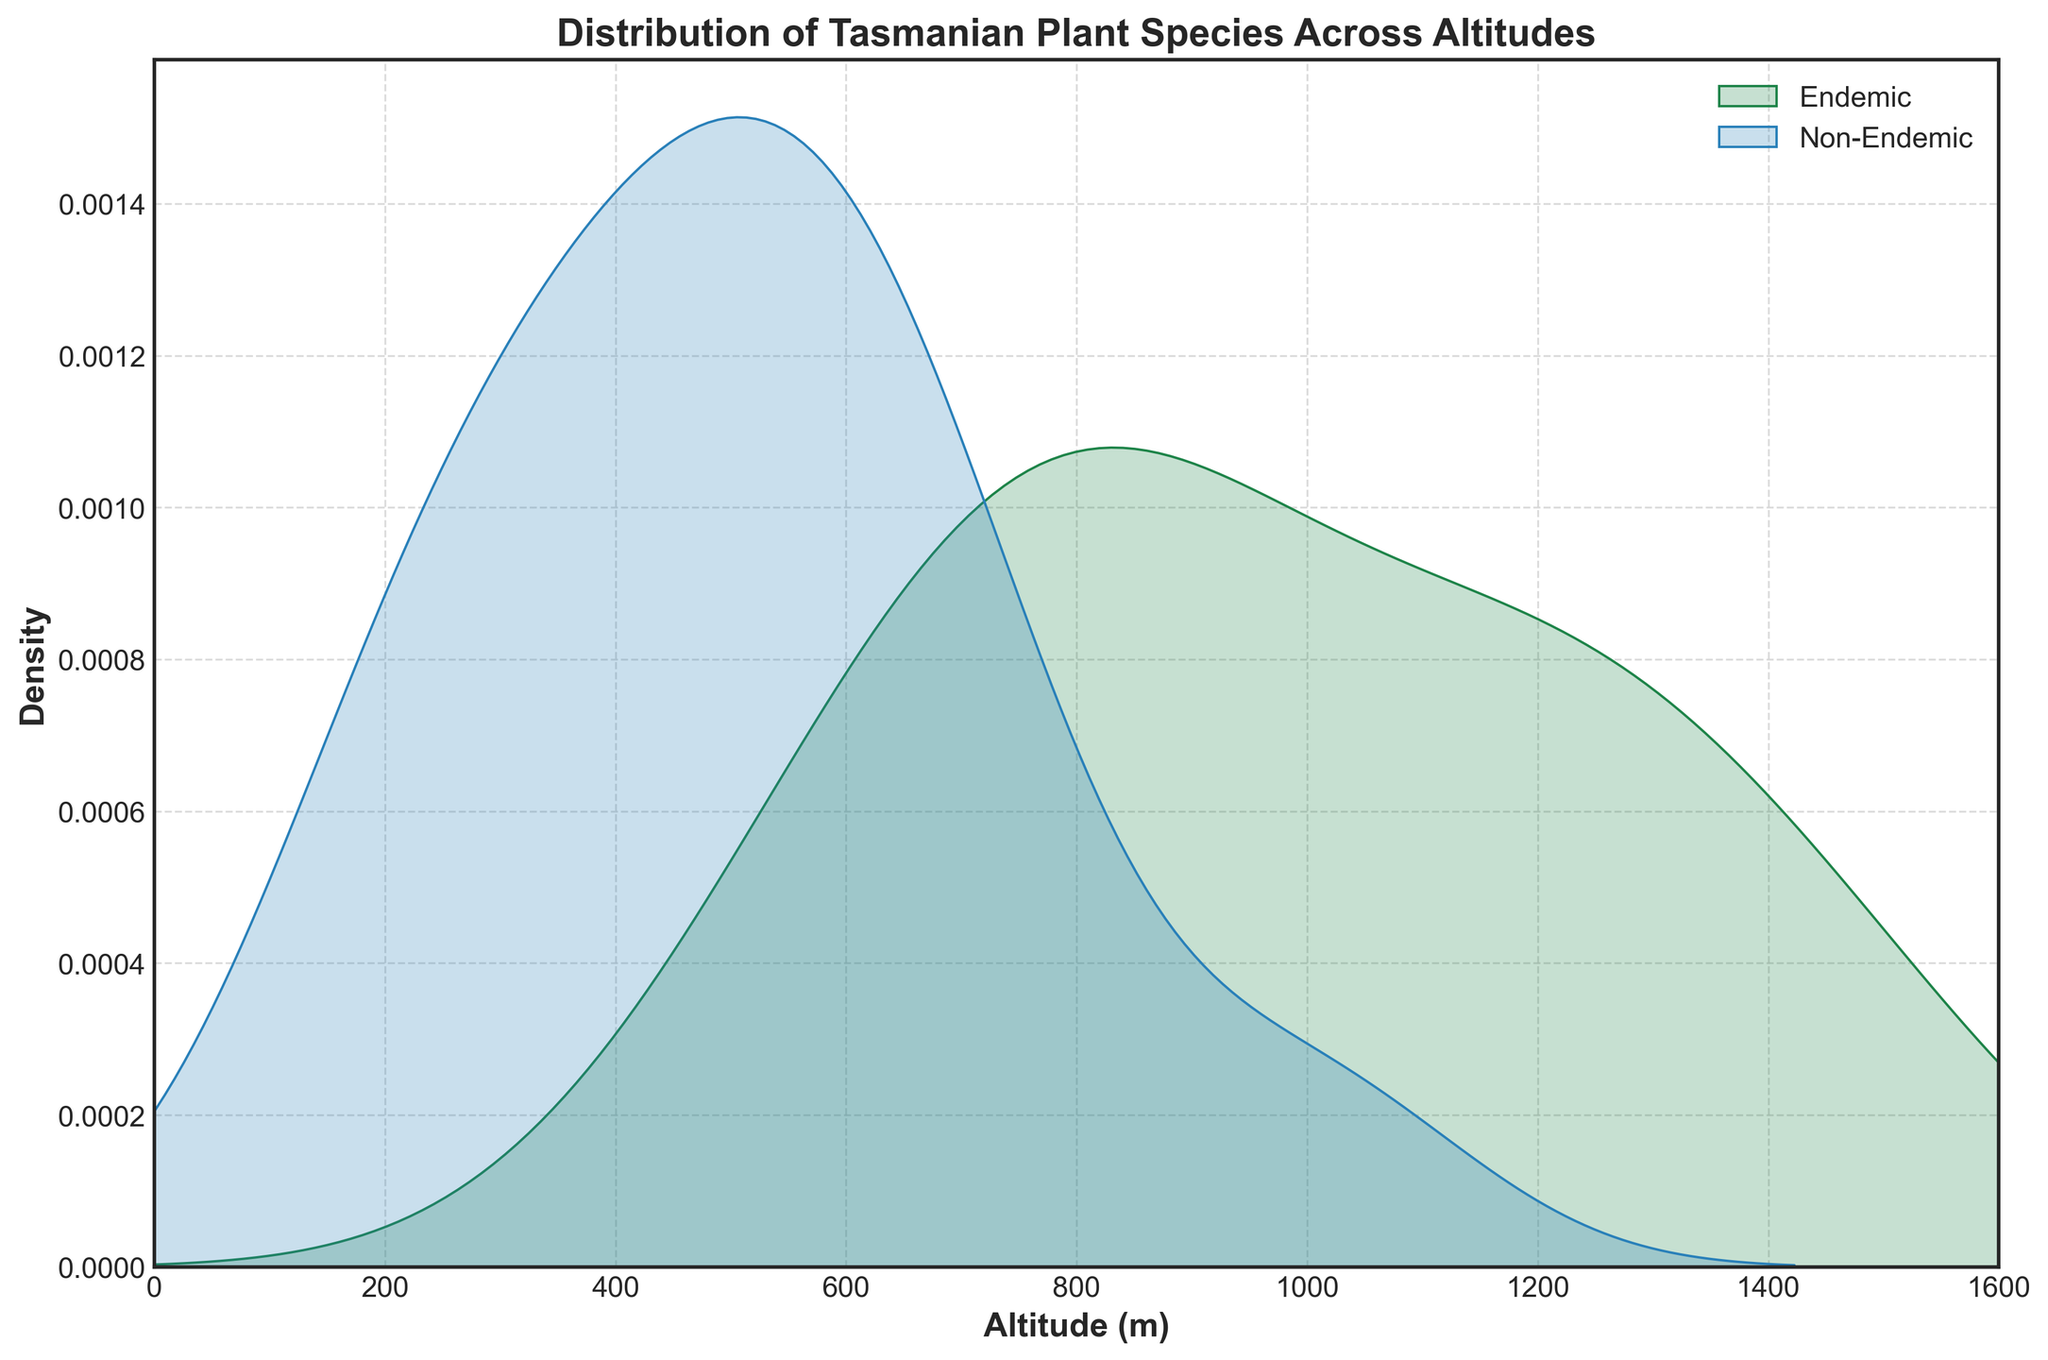What is the title of the plot? The title is usually placed at the top of the plot and provides the main description of what the plot is about. In this case, it is "Distribution of Tasmanian Plant Species Across Altitudes".
Answer: Distribution of Tasmanian Plant Species Across Altitudes What are the colors used to represent endemic and non-endemic species? The plot uses different colors to distinguish between endemic and non-endemic species, which are denoted in the legend. The color for endemic species is '#1e8449', a shade of green, and for non-endemic species is '#2980b9', a shade of blue.
Answer: Green for Endemic, Blue for Non-Endemic Which altitude range shows the highest density for endemic species? By analyzing the density plot for the endemic species (green shade), we can see that the highest peak, indicating the highest density, is around the 700-800 meter range.
Answer: 700-800 meters Do endemic or non-endemic species show a wider altitude distribution? To determine this, we compare the spread of the two density plots. The density plot of the non-endemic species (blue shade) spreads across altitudes from 200 to around 1600 meters, indicating a wider distribution compared to the endemic species (green shade), which is more concentrated between 500 and 1500 meters.
Answer: Non-Endemic species At which altitude do both endemic and non-endemic species show notable density overlap? Observing the plot, we look for altitudes where both density plots (green and blue) have overlapping areas. Notable density overlap is around the 700-900 meter range.
Answer: 700-900 meters What can be inferred about the density of species at lower altitudes (0-500 meters)? Looking at the density plots within the 0 to 500 meter range, non-endemic species (blue shade) show a significant density while endemic species (green shade) have minimal density in this range. This indicates more non-endemic species thrive at lower altitudes compared to endemic species.
Answer: More non-endemic species at lower altitudes What is the range of altitudes covered by endemic species? The altitudes covered by endemic species can be determined by noting the spread of the green density plot. Endemic species are present from approximately 500 to 1500 meters.
Answer: 500-1500 meters Are there any altitudes where no species are present according to the plot? Checking both density plots for any altitude with zero density, we see that no species are present at the extreme low (0-200 meters) and high (1500-1600 meters) ends.
Answer: 0-200 meters, 1500-1600 meters Which species group shows more peaks in their density distribution? Comparing the plot features, the density distribution of non-endemic species (blue) shows more peaks and varied density, indicating more variation in altitude preferences compared to endemic species (green).
Answer: Non-Endemic species What is the altitude range with the least density for both endemic and non-endemic species? By identifying the altitude ranges where both density plots are at or near zero, the least density range for both is from around 0 to 200 meters and 1500 to 1600 meters.
Answer: 0-200 meters, 1500-1600 meters 